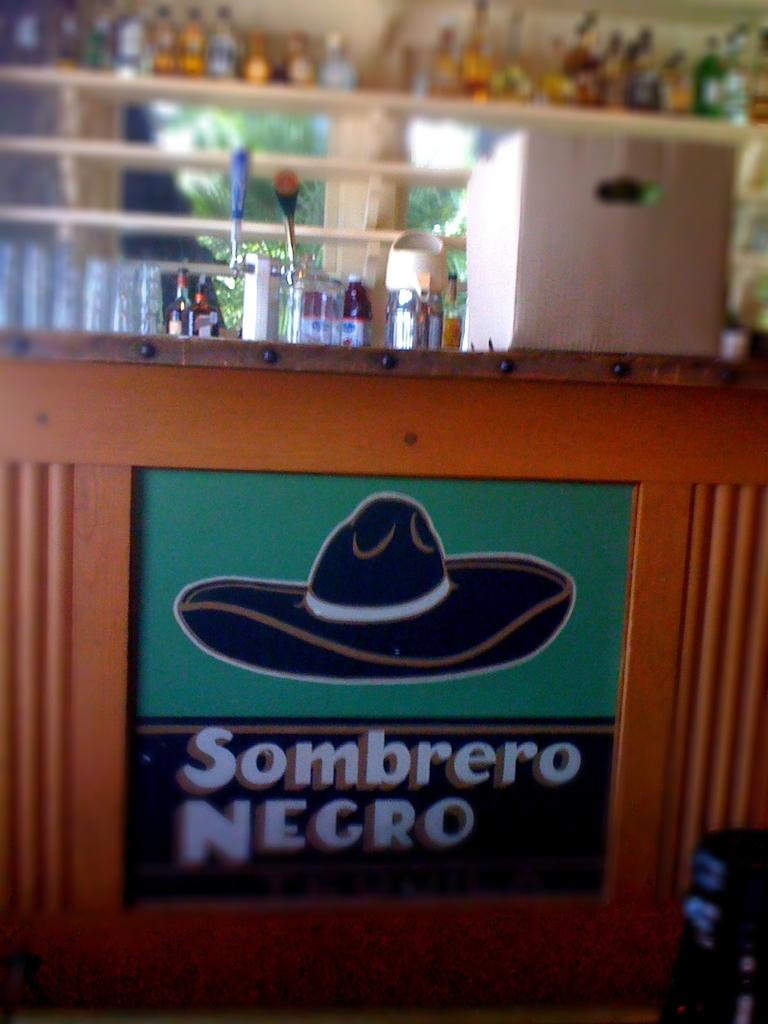<image>
Offer a succinct explanation of the picture presented. A picture of a sombrero, it is described as a black sombrero 